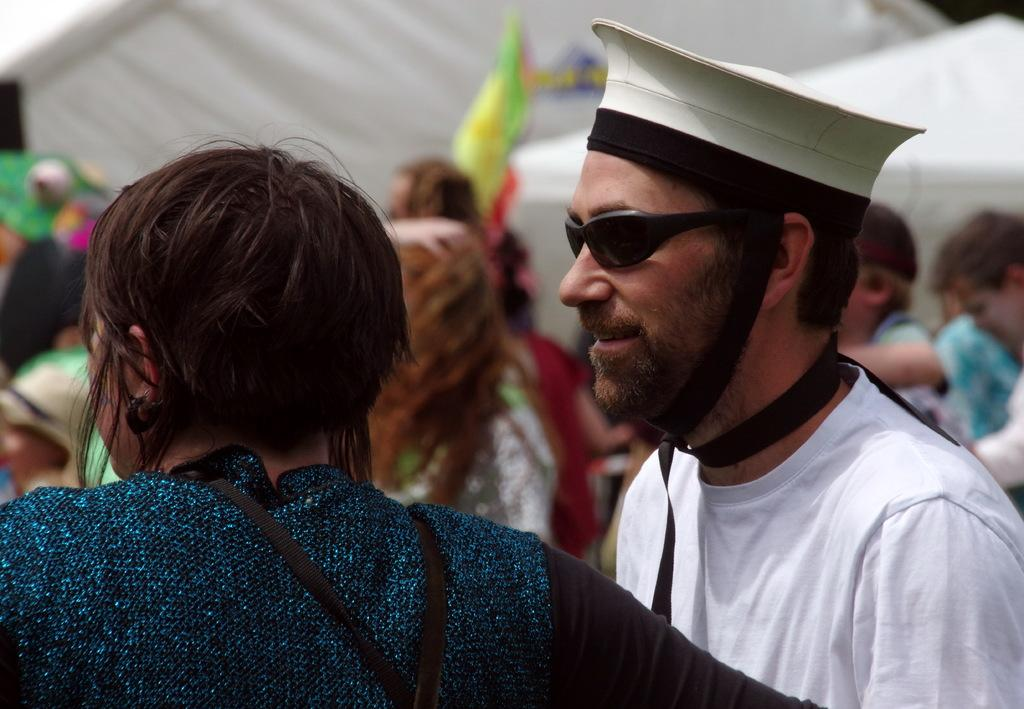Who or what can be seen in the image? There are people in the image. How are the people arranged in the image? The people are positioned from left to right. What can be seen in the background of the image? There are tents in the background of the image. Where is the owl perched in the image? There is no owl present in the image. What type of basin can be seen in the image? There is no basin present in the image. 